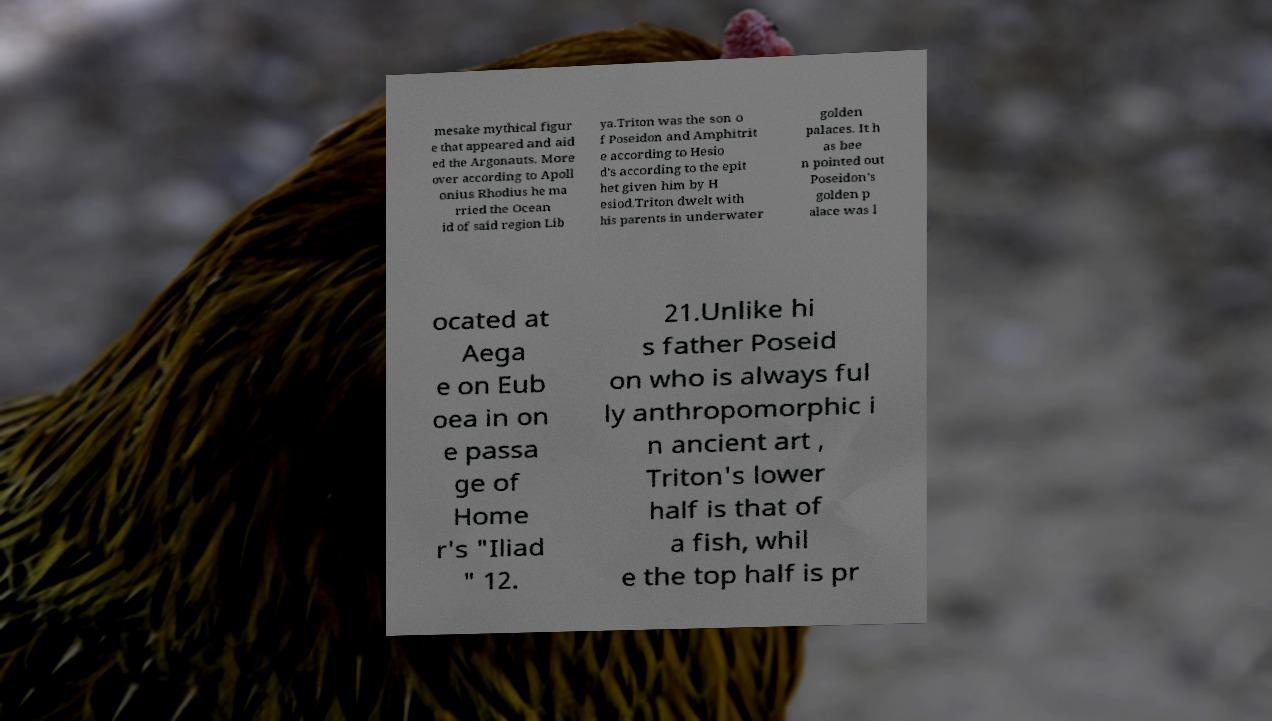Could you assist in decoding the text presented in this image and type it out clearly? mesake mythical figur e that appeared and aid ed the Argonauts. More over according to Apoll onius Rhodius he ma rried the Ocean id of said region Lib ya.Triton was the son o f Poseidon and Amphitrit e according to Hesio d's according to the epit het given him by H esiod.Triton dwelt with his parents in underwater golden palaces. It h as bee n pointed out Poseidon's golden p alace was l ocated at Aega e on Eub oea in on e passa ge of Home r's "Iliad " 12. 21.Unlike hi s father Poseid on who is always ful ly anthropomorphic i n ancient art , Triton's lower half is that of a fish, whil e the top half is pr 